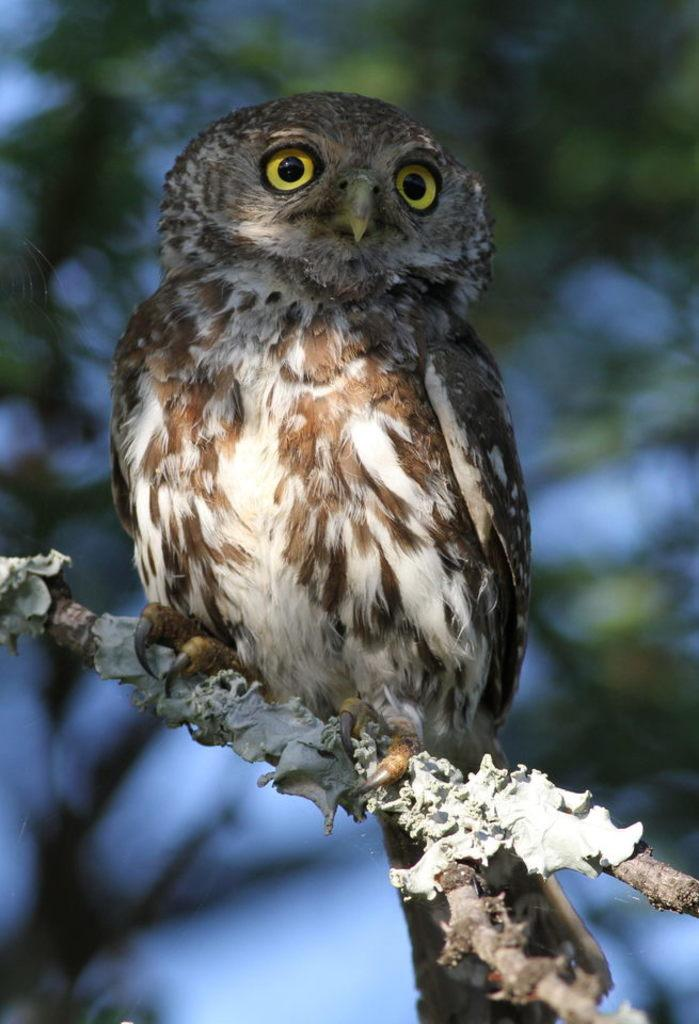What type of animal can be seen in the image? There is a bird in the image. Where is the bird located in the image? The bird is sitting on a branch of a tree. What is the main object in the image? There is a tree in the image. Can you describe the background of the image? The background of the image is blurred. What type of prose can be heard in the background of the image? There is no prose or sound present in the image; it is a still image of a bird on a tree branch. 